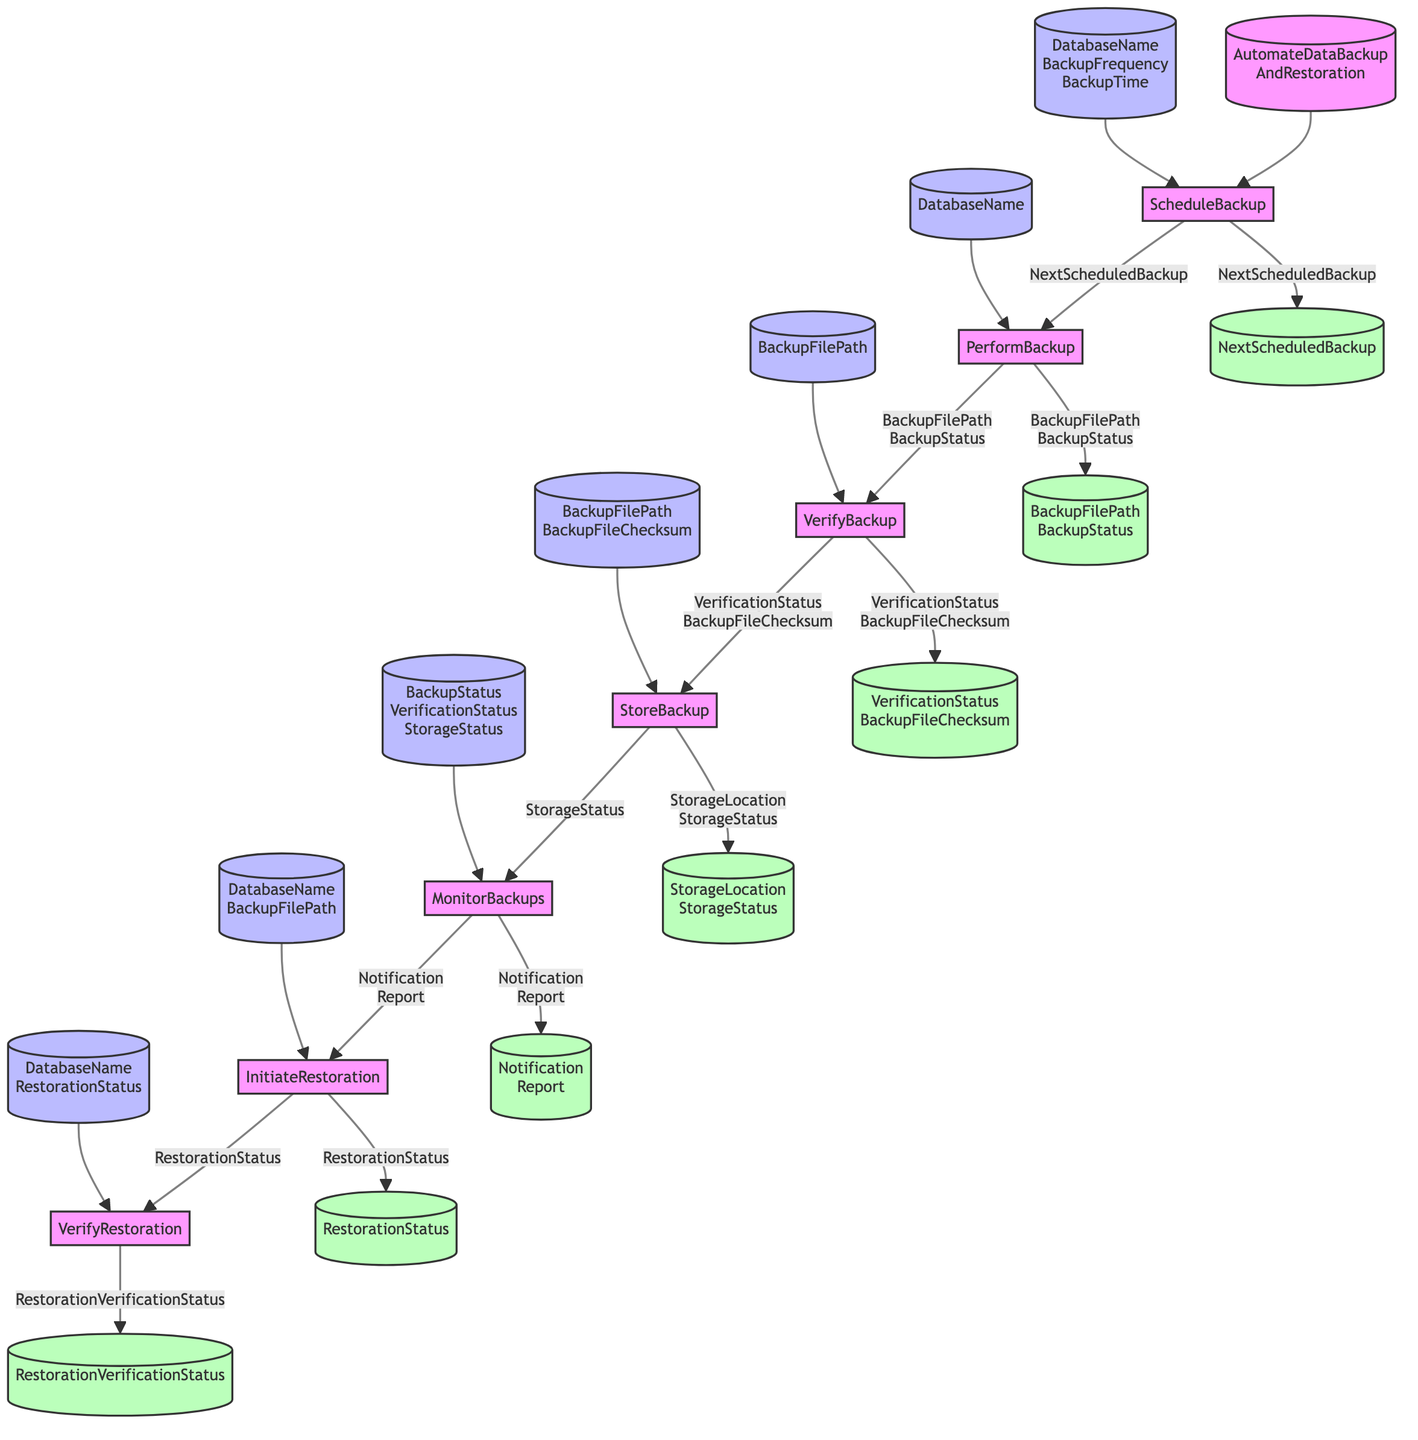What is the first step in the process? The first step in the flowchart is labeled "ScheduleBackup," indicating this is where the process begins.
Answer: ScheduleBackup How many outputs does the "PerformBackup" step produce? The "PerformBackup" step has two outputs, which are "BackupFilePath" and "BackupStatus," as shown by the two values leading out from this node.
Answer: Two What inputs does "StoreBackup" require? The "StoreBackup" step requires two inputs: "BackupFilePath" and "BackupFileChecksum," which are indicated as part of the flow toward this node.
Answer: BackupFilePath, BackupFileChecksum What is the output of "MonitorBackups"? The output of "MonitorBackups" is represented as two values: "Notification" and "Report," which indicates what this step produces for the next stage.
Answer: Notification, Report Which step follows "VerifyBackup"? After "VerifyBackup," the next step in the sequence is "StoreBackup," demonstrating the direct flow from verification to storage in the diagram.
Answer: StoreBackup What is the final output in this process? The final output in the process, indicated by the last node, is "RestorationVerificationStatus," which represents the outcome of the restoration verification step.
Answer: RestorationVerificationStatus How many total steps are involved in the backup and restoration function? The flowchart outlines a total of seven steps in the backup and restoration function, counting from "ScheduleBackup" to "VerifyRestoration."
Answer: Seven What happens if the "BackupStatus" is not successful? If the "BackupStatus" is not successful, the "MonitorBackups" must handle the failure situation, implying that monitoring is crucial for error handling.
Answer: Handle failures Which step directly leads to "InitiateRestoration"? The "MonitorBackups" step directly leads to "InitiateRestoration," as it indicates a transition based on the monitoring outcomes of the backup processes.
Answer: MonitorBackups 